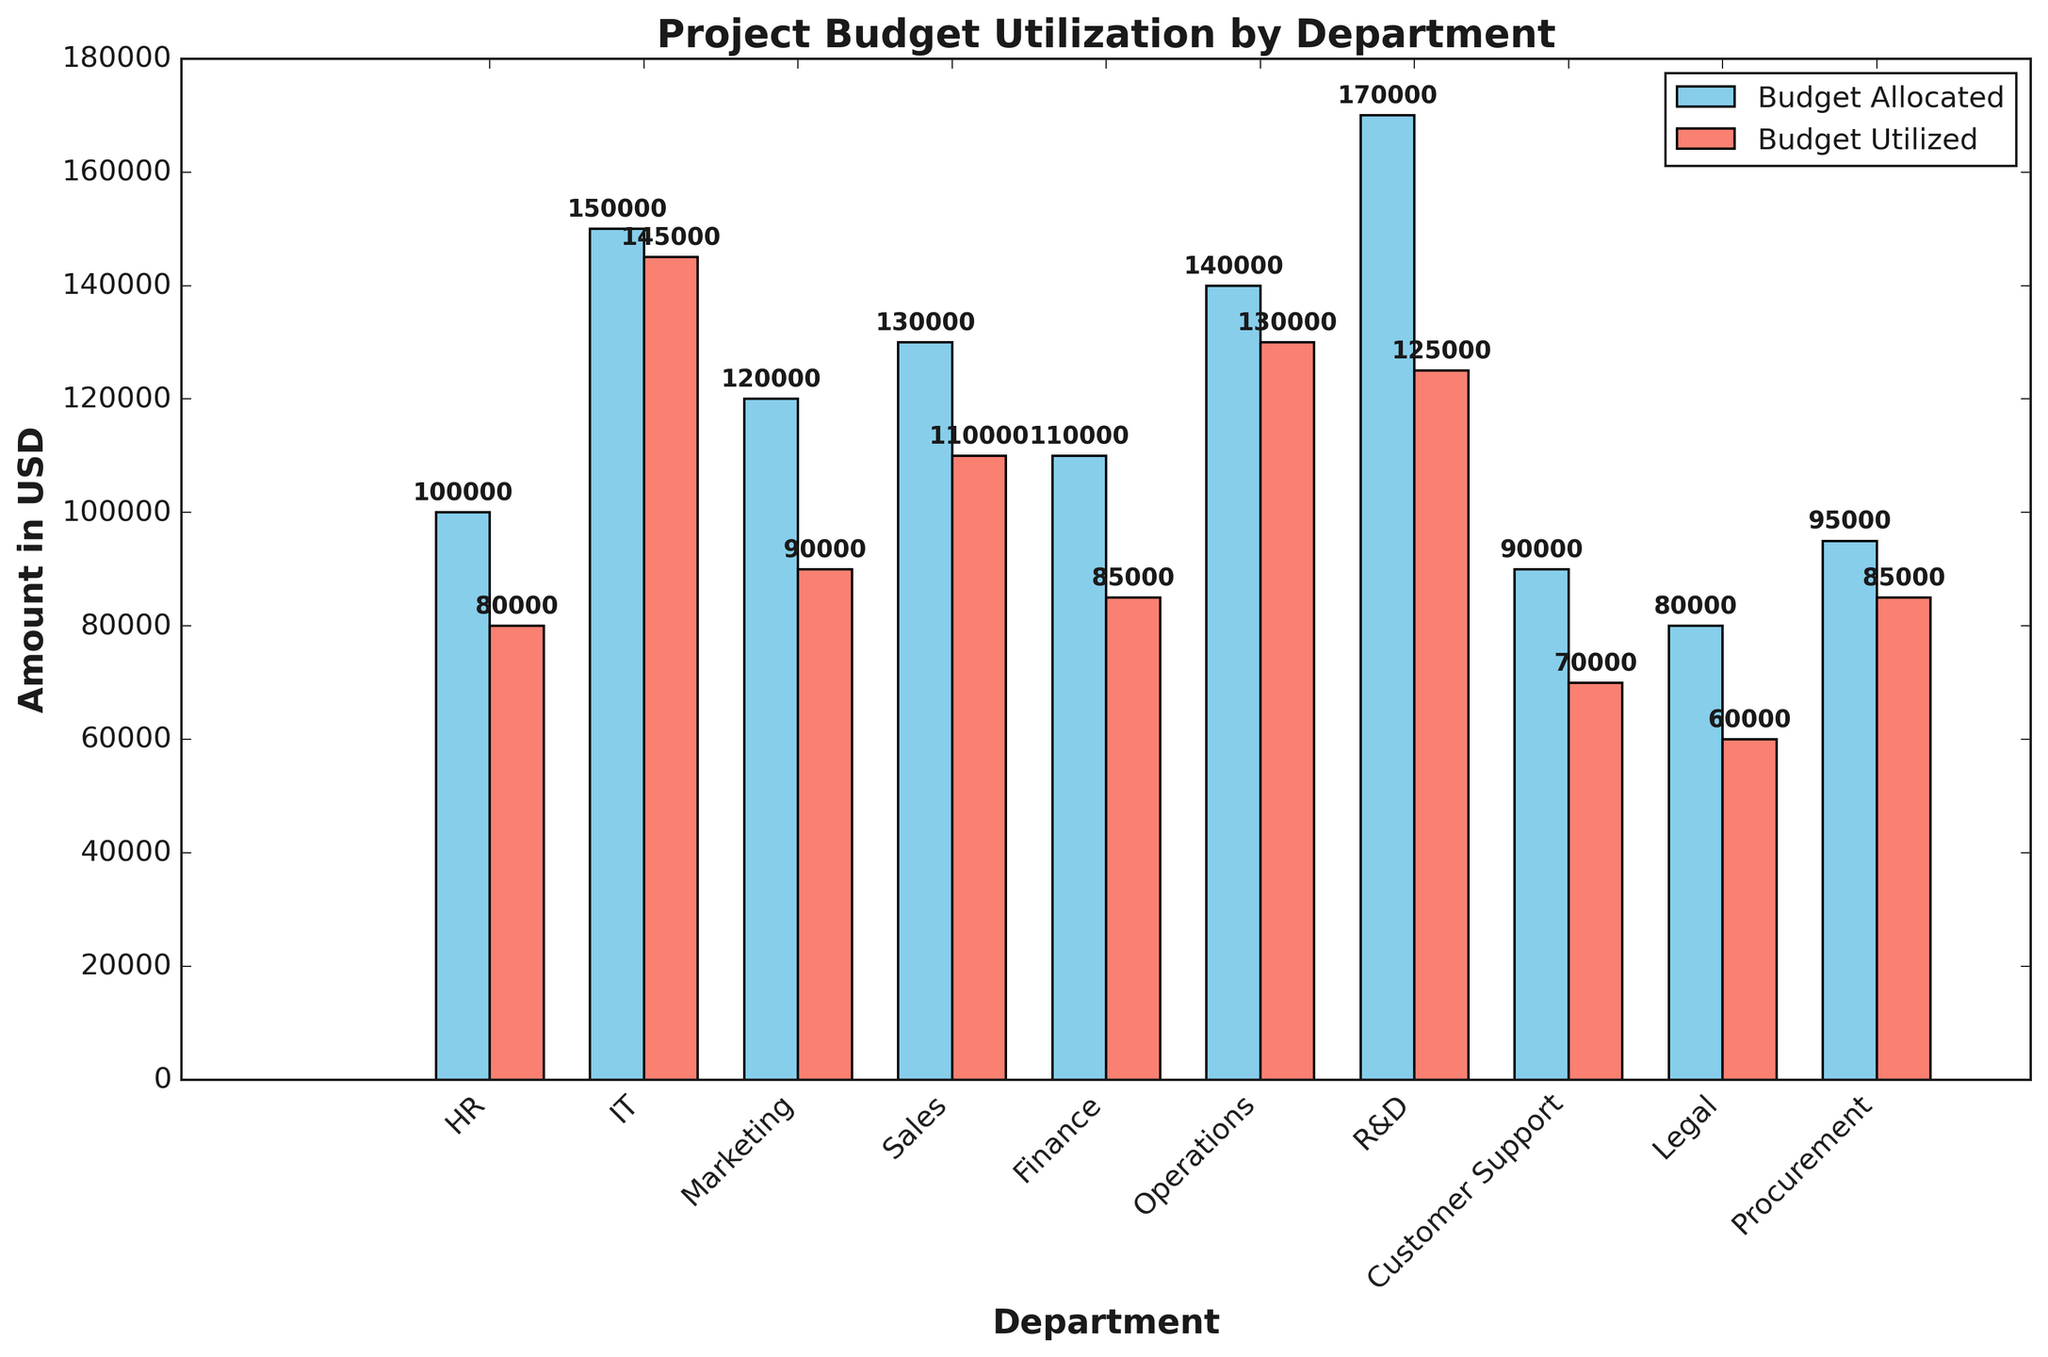Which department has the highest budget utilization? The length of the bar for IT's budget utilization is higher than any other department.
Answer: IT Which two departments have the closest budget utilization? HR utilized $80,000 and Procurement utilized $85,000, the difference is only $5,000.
Answer: HR and Procurement By how much does the Operations' budget utilization exceed the Finance's budget utilization? Operations utilized $130,000 while Finance utilized $85,000, so the difference is $130,000 - $85,000 = $45,000.
Answer: $45,000 Which department has the greatest discrepancy between budget allocated and budget utilized? HR's budget allocated and budget utilized have a difference of $20,000, which is the largest among the departments.
Answer: HR What is the total budget utilized by the HR, IT, and Marketing departments? HR utilized $80,000, IT utilized $145,000, and Marketing utilized $90,000. So, the total is $80,000 + $145,000 + $90,000 = $315,000.
Answer: $315,000 Which departments have utilized less than 80% of their allocated budget? HR utilized $80,000 out of $100,000, Marketing utilized $90,000 out of $120,000, Finance utilized $85,000 out of $110,000, R&D utilized $125,000 out of $170,000, Customer Support utilized $70,000 out of $90,000, and Legal utilized $60,000 out of $80,000. For each, the utilization is less than 80% of the allocated budget.
Answer: HR, Marketing, Finance, R&D, Customer Support, Legal Compare the budget allocated and utilized for the departments with the second highest budgets. R&D has the second highest budget allocation at $170,000 and utilized $125,000.
Answer: R&D: $170,000 allocated, $125,000 utilized What is the average budget utilization across all departments? The total budget utilized is $965,000 and there are 10 departments, so the average utilization is $965,000 / 10 = $96,500.
Answer: $96,500 